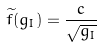<formula> <loc_0><loc_0><loc_500><loc_500>{ \widetilde { f } } ( g _ { I } ) = \frac { c } { \sqrt { g _ { I } } }</formula> 